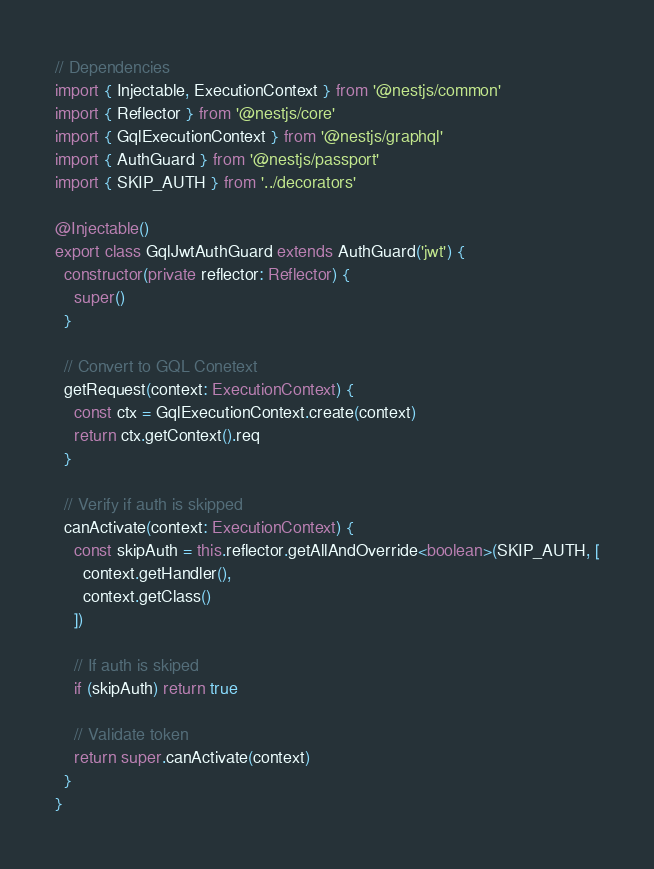Convert code to text. <code><loc_0><loc_0><loc_500><loc_500><_TypeScript_>// Dependencies
import { Injectable, ExecutionContext } from '@nestjs/common'
import { Reflector } from '@nestjs/core'
import { GqlExecutionContext } from '@nestjs/graphql'
import { AuthGuard } from '@nestjs/passport'
import { SKIP_AUTH } from '../decorators'

@Injectable()
export class GqlJwtAuthGuard extends AuthGuard('jwt') {
  constructor(private reflector: Reflector) {
    super()
  }

  // Convert to GQL Conetext
  getRequest(context: ExecutionContext) {
    const ctx = GqlExecutionContext.create(context)
    return ctx.getContext().req
  }

  // Verify if auth is skipped
  canActivate(context: ExecutionContext) {
    const skipAuth = this.reflector.getAllAndOverride<boolean>(SKIP_AUTH, [
      context.getHandler(),
      context.getClass()
    ])

    // If auth is skiped
    if (skipAuth) return true
    
    // Validate token
    return super.canActivate(context)
  }
}</code> 